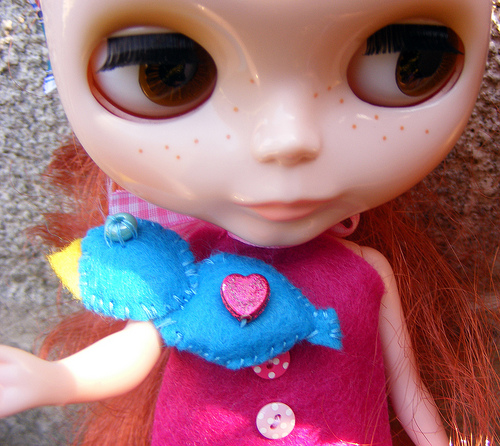<image>
Can you confirm if the bird is under the head? Yes. The bird is positioned underneath the head, with the head above it in the vertical space. 